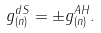<formula> <loc_0><loc_0><loc_500><loc_500>g _ { ( n ) } ^ { d S } = \pm g _ { ( n ) } ^ { A H } .</formula> 